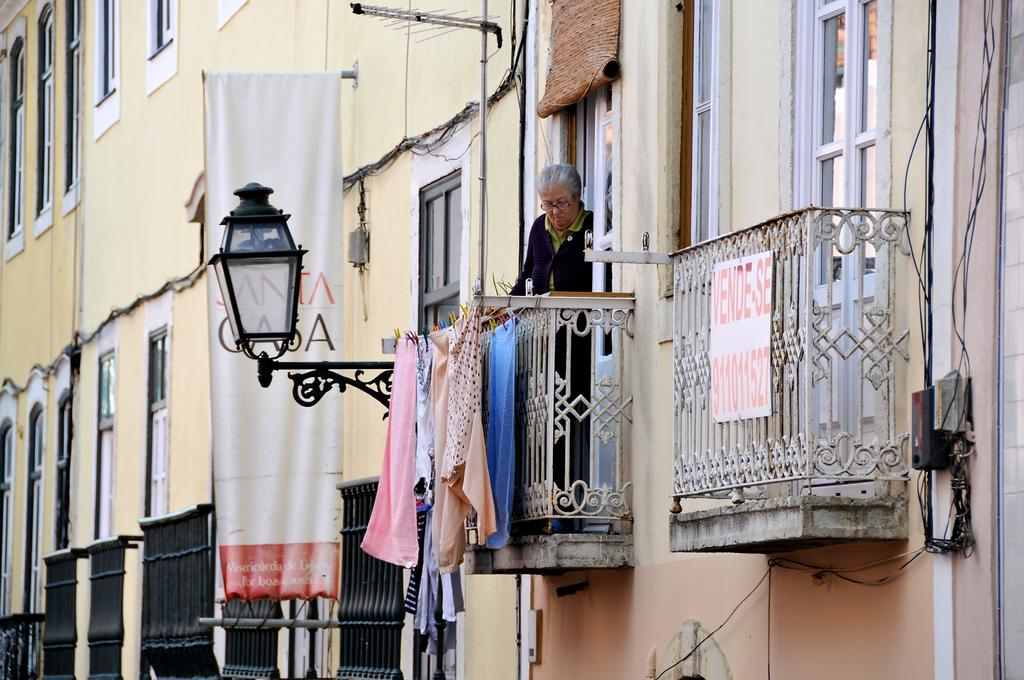What type of openings can be seen in the image? There are windows in the image. What items are visible in the image that people might wear? There are clothes in the image. Is there a person present in the image? Yes, there is a person in the image. What type of structures can be seen in the image? There are grilles in the image. What is a flat, rectangular object present in the image? There is a board in the image. What is a long, narrow piece of cloth with writing on it in the image? There is a banner in the image. What type of lighting fixture is visible in the image? There is a lamp in the image. What type of containers can be seen in the image? There are boxes in the image. What type of wires or cords are present in the image? There are cables in the image. What general term can be used to describe the various items in the image? There are objects in the image. What type of music is being played by the government in the image? There is no mention of music or government in the image; it features windows, clothes, a person, grilles, a board, a banner, a lamp, boxes, cables, and various objects. What part of the person's body is visible in the image? The image does not show any specific body parts of the person; only their presence is mentioned. 